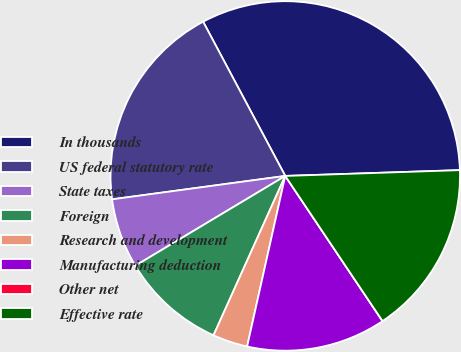Convert chart. <chart><loc_0><loc_0><loc_500><loc_500><pie_chart><fcel>In thousands<fcel>US federal statutory rate<fcel>State taxes<fcel>Foreign<fcel>Research and development<fcel>Manufacturing deduction<fcel>Other net<fcel>Effective rate<nl><fcel>32.26%<fcel>19.35%<fcel>6.45%<fcel>9.68%<fcel>3.23%<fcel>12.9%<fcel>0.0%<fcel>16.13%<nl></chart> 